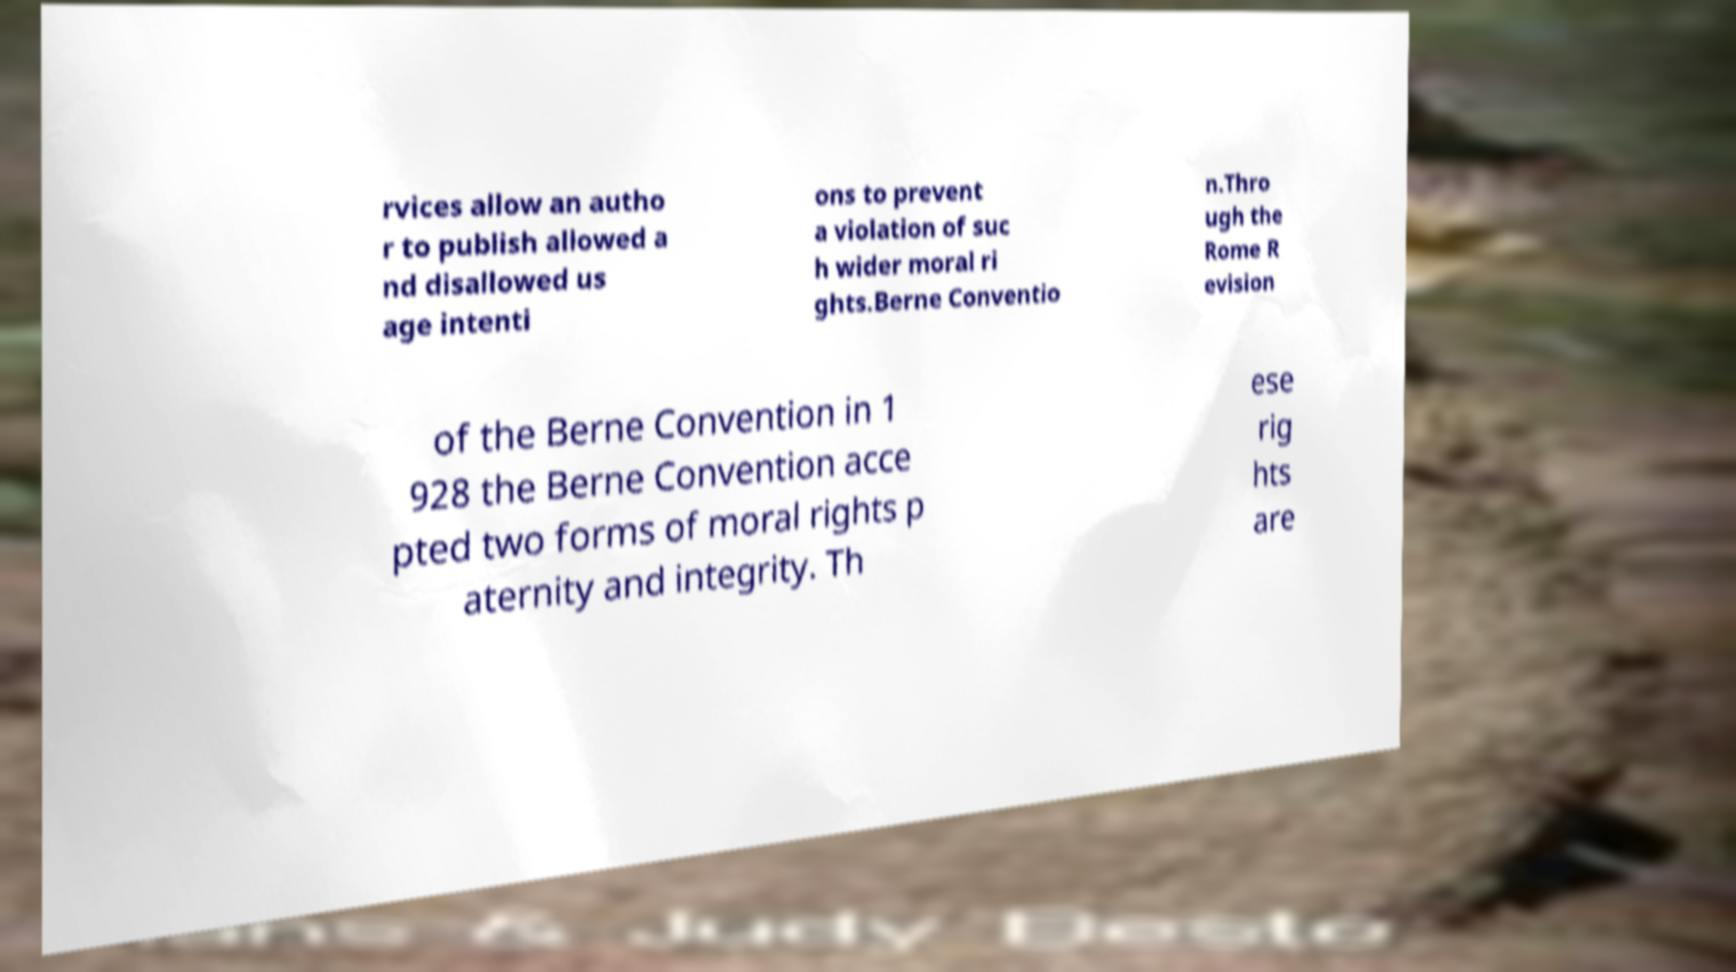Can you accurately transcribe the text from the provided image for me? rvices allow an autho r to publish allowed a nd disallowed us age intenti ons to prevent a violation of suc h wider moral ri ghts.Berne Conventio n.Thro ugh the Rome R evision of the Berne Convention in 1 928 the Berne Convention acce pted two forms of moral rights p aternity and integrity. Th ese rig hts are 